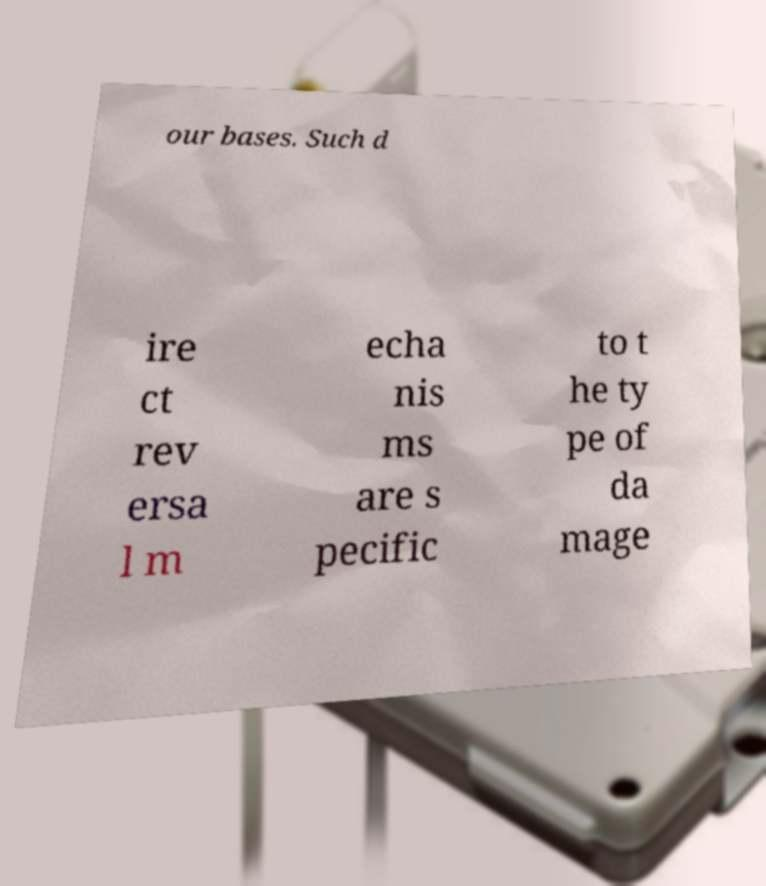What messages or text are displayed in this image? I need them in a readable, typed format. our bases. Such d ire ct rev ersa l m echa nis ms are s pecific to t he ty pe of da mage 